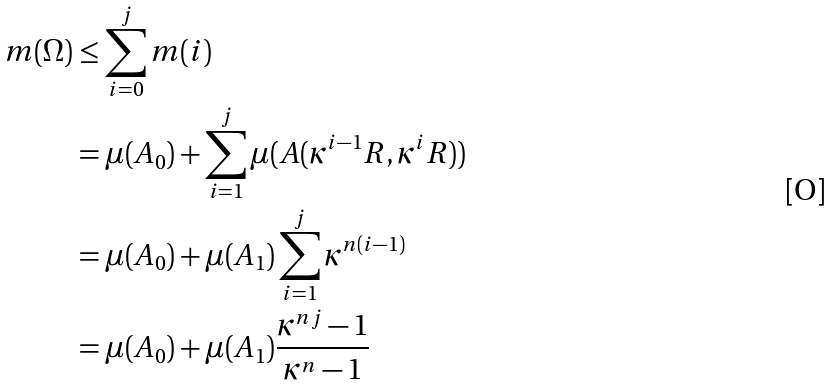Convert formula to latex. <formula><loc_0><loc_0><loc_500><loc_500>m ( \Omega ) & \leq \sum _ { i = 0 } ^ { j } m ( i ) \\ & = \mu ( A _ { 0 } ) + \sum _ { i = 1 } ^ { j } \mu ( A ( \kappa ^ { i - 1 } R , \kappa ^ { i } R ) ) \\ & = \mu ( A _ { 0 } ) + \mu ( A _ { 1 } ) \sum _ { i = 1 } ^ { j } \kappa ^ { n ( i - 1 ) } \\ & = \mu ( A _ { 0 } ) + \mu ( A _ { 1 } ) \frac { \kappa ^ { n j } - 1 } { \kappa ^ { n } - 1 }</formula> 